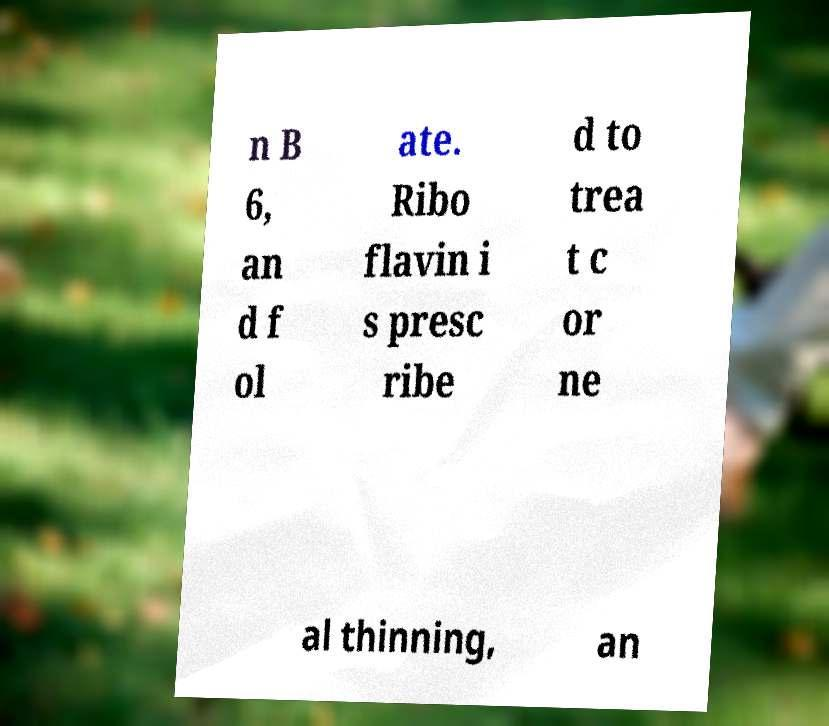There's text embedded in this image that I need extracted. Can you transcribe it verbatim? n B 6, an d f ol ate. Ribo flavin i s presc ribe d to trea t c or ne al thinning, an 